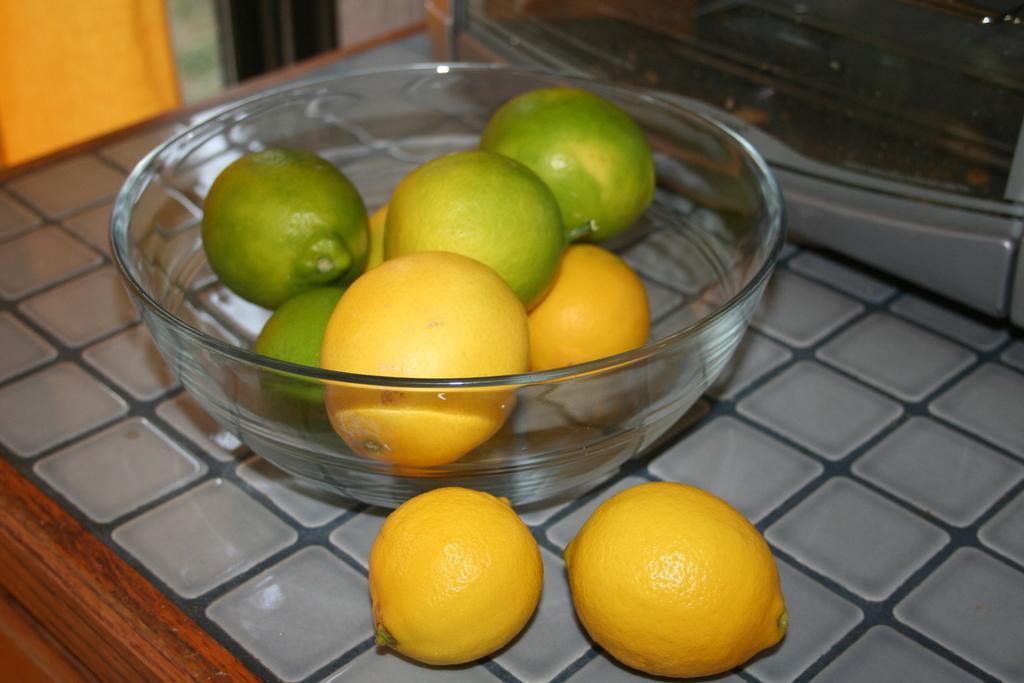Describe this image in one or two sentences. In this image, we can see lemons in the glass bowl and on the surface. At the top of the image, we can see an object and blur view. In the bottom left corner, there is a wooden object. 